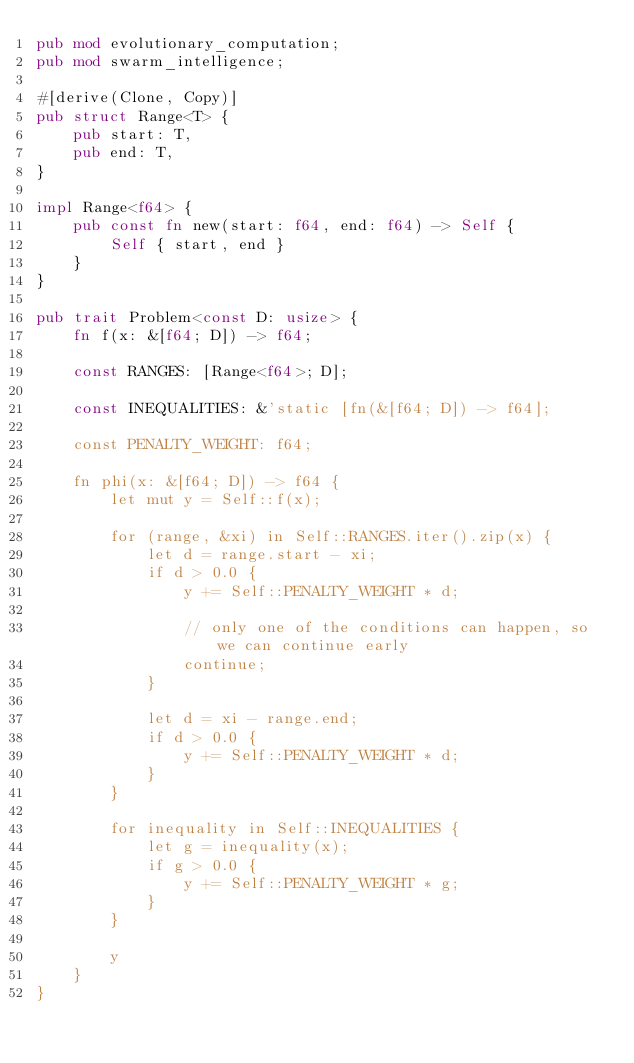Convert code to text. <code><loc_0><loc_0><loc_500><loc_500><_Rust_>pub mod evolutionary_computation;
pub mod swarm_intelligence;

#[derive(Clone, Copy)]
pub struct Range<T> {
    pub start: T,
    pub end: T,
}

impl Range<f64> {
    pub const fn new(start: f64, end: f64) -> Self {
        Self { start, end }
    }
}

pub trait Problem<const D: usize> {
    fn f(x: &[f64; D]) -> f64;

    const RANGES: [Range<f64>; D];

    const INEQUALITIES: &'static [fn(&[f64; D]) -> f64];

    const PENALTY_WEIGHT: f64;

    fn phi(x: &[f64; D]) -> f64 {
        let mut y = Self::f(x);

        for (range, &xi) in Self::RANGES.iter().zip(x) {
            let d = range.start - xi;
            if d > 0.0 {
                y += Self::PENALTY_WEIGHT * d;

                // only one of the conditions can happen, so we can continue early
                continue;
            }

            let d = xi - range.end;
            if d > 0.0 {
                y += Self::PENALTY_WEIGHT * d;
            }
        }

        for inequality in Self::INEQUALITIES {
            let g = inequality(x);
            if g > 0.0 {
                y += Self::PENALTY_WEIGHT * g;
            }
        }

        y
    }
}
</code> 